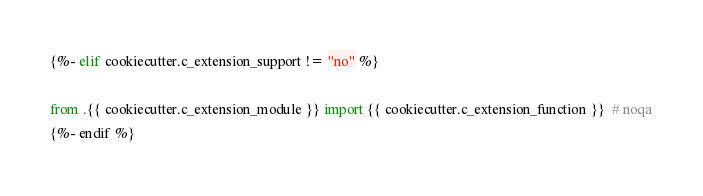Convert code to text. <code><loc_0><loc_0><loc_500><loc_500><_Python_>{%- elif cookiecutter.c_extension_support != "no" %}

from .{{ cookiecutter.c_extension_module }} import {{ cookiecutter.c_extension_function }}  # noqa
{%- endif %}
</code> 